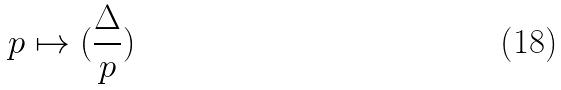<formula> <loc_0><loc_0><loc_500><loc_500>p \mapsto ( \frac { \Delta } { p } )</formula> 